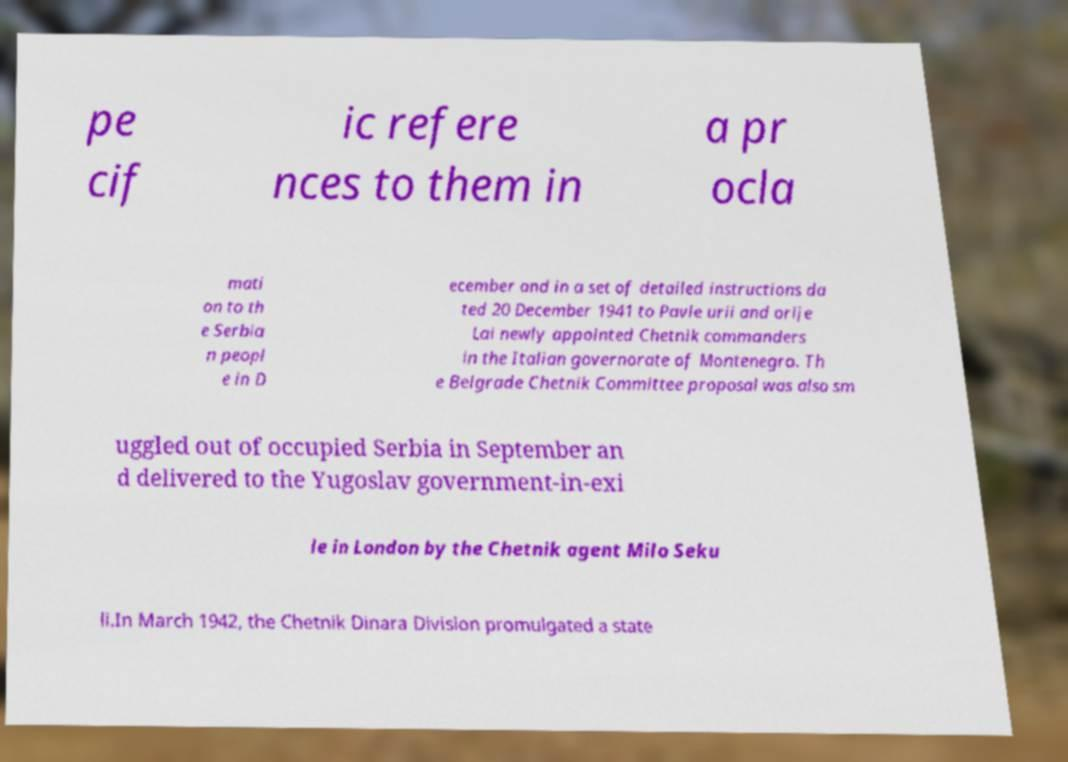For documentation purposes, I need the text within this image transcribed. Could you provide that? pe cif ic refere nces to them in a pr ocla mati on to th e Serbia n peopl e in D ecember and in a set of detailed instructions da ted 20 December 1941 to Pavle urii and orije Lai newly appointed Chetnik commanders in the Italian governorate of Montenegro. Th e Belgrade Chetnik Committee proposal was also sm uggled out of occupied Serbia in September an d delivered to the Yugoslav government-in-exi le in London by the Chetnik agent Milo Seku li.In March 1942, the Chetnik Dinara Division promulgated a state 